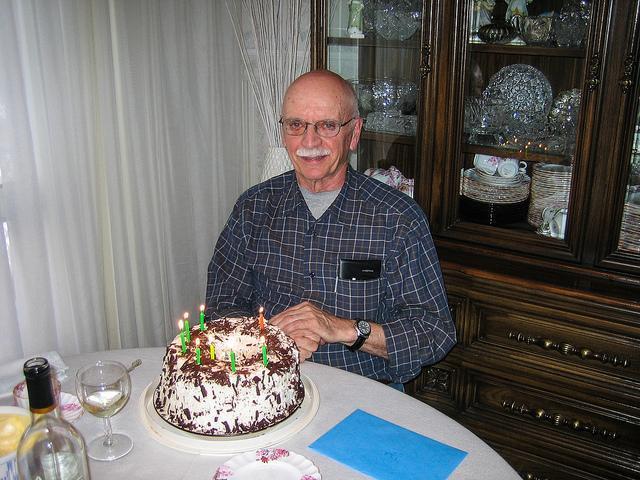How many candles are on the cake?
Give a very brief answer. 8. How many palm trees are to the right of the orange bus?
Give a very brief answer. 0. 